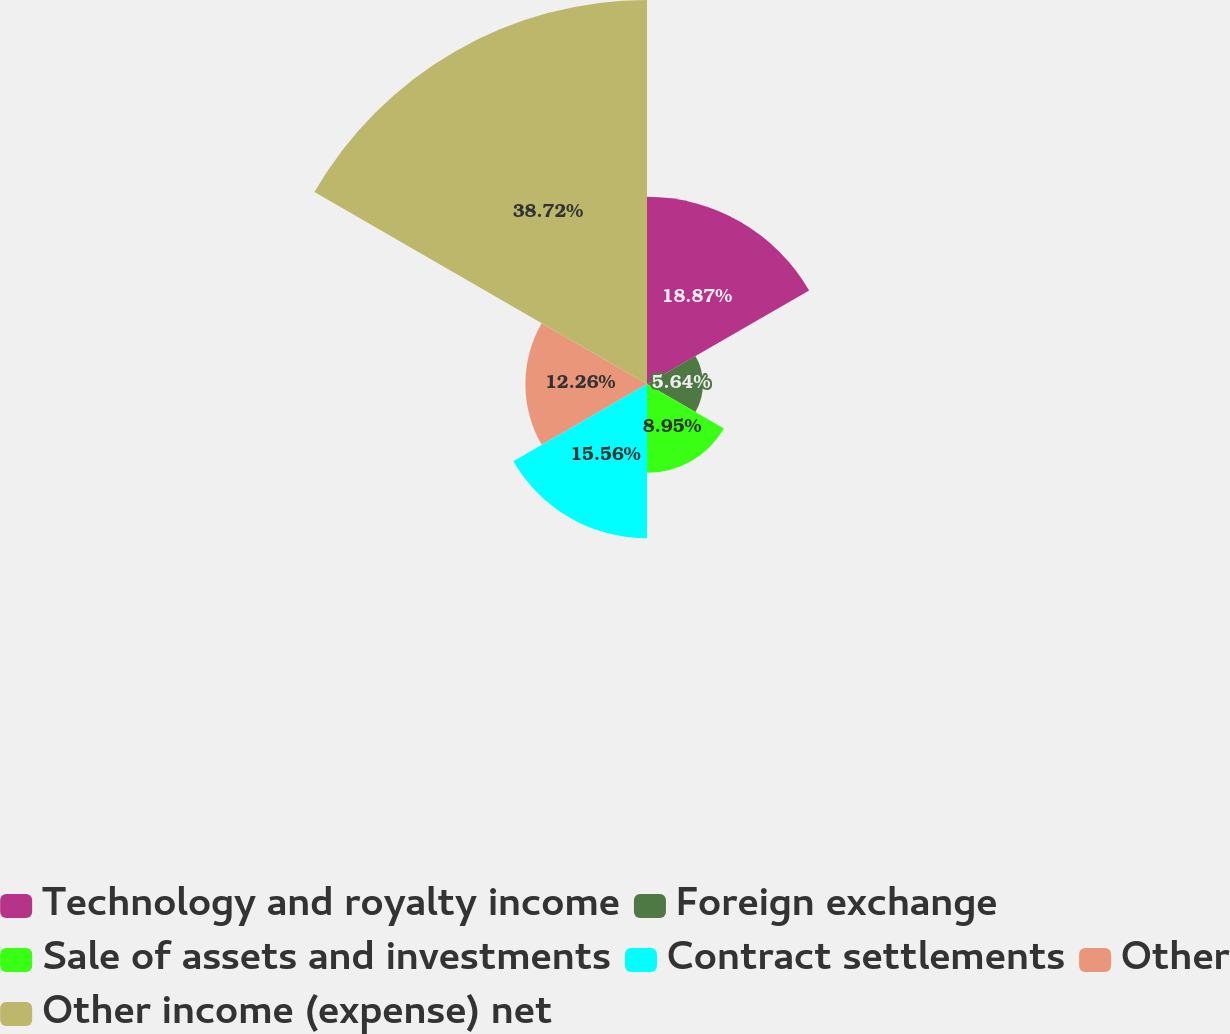Convert chart. <chart><loc_0><loc_0><loc_500><loc_500><pie_chart><fcel>Technology and royalty income<fcel>Foreign exchange<fcel>Sale of assets and investments<fcel>Contract settlements<fcel>Other<fcel>Other income (expense) net<nl><fcel>18.87%<fcel>5.64%<fcel>8.95%<fcel>15.56%<fcel>12.26%<fcel>38.71%<nl></chart> 